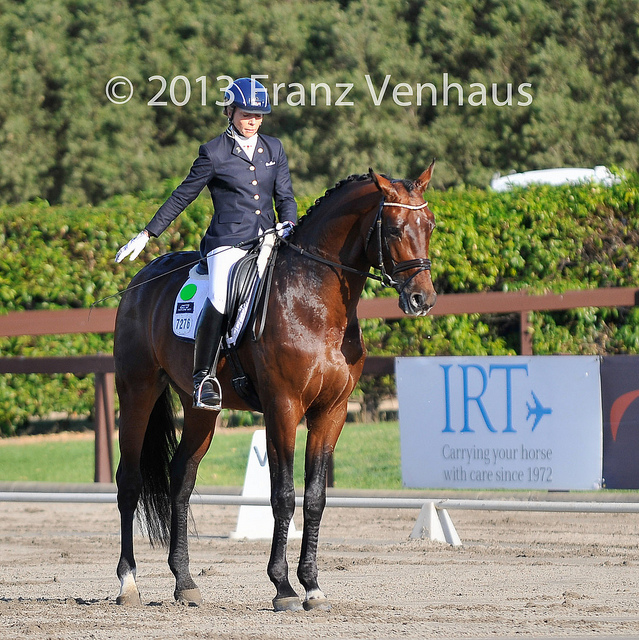Please extract the text content from this image. IRT &#169; 2013 Franz Venhaus 7276 V With care Since 1972 horse YOUR Carrying 